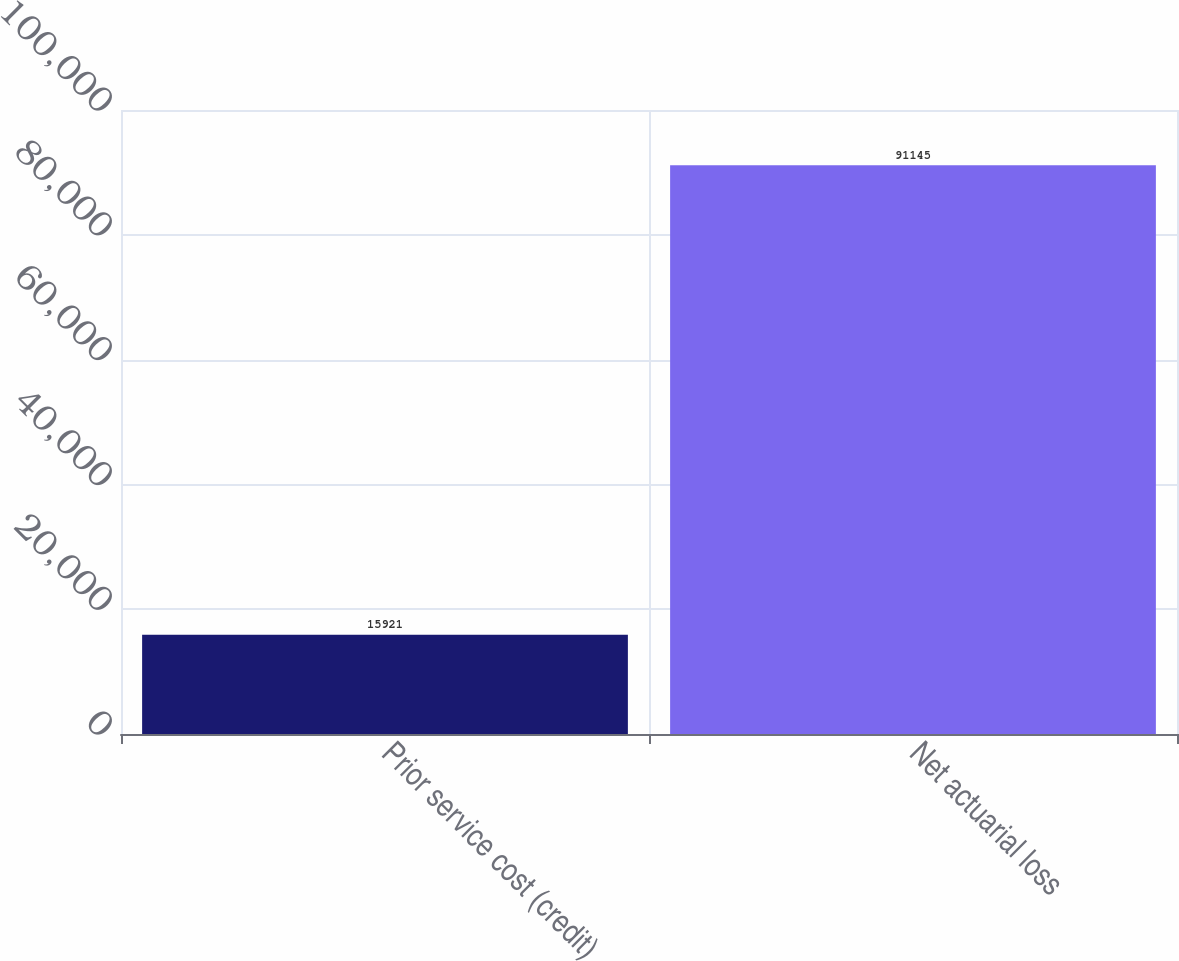Convert chart. <chart><loc_0><loc_0><loc_500><loc_500><bar_chart><fcel>Prior service cost (credit)<fcel>Net actuarial loss<nl><fcel>15921<fcel>91145<nl></chart> 